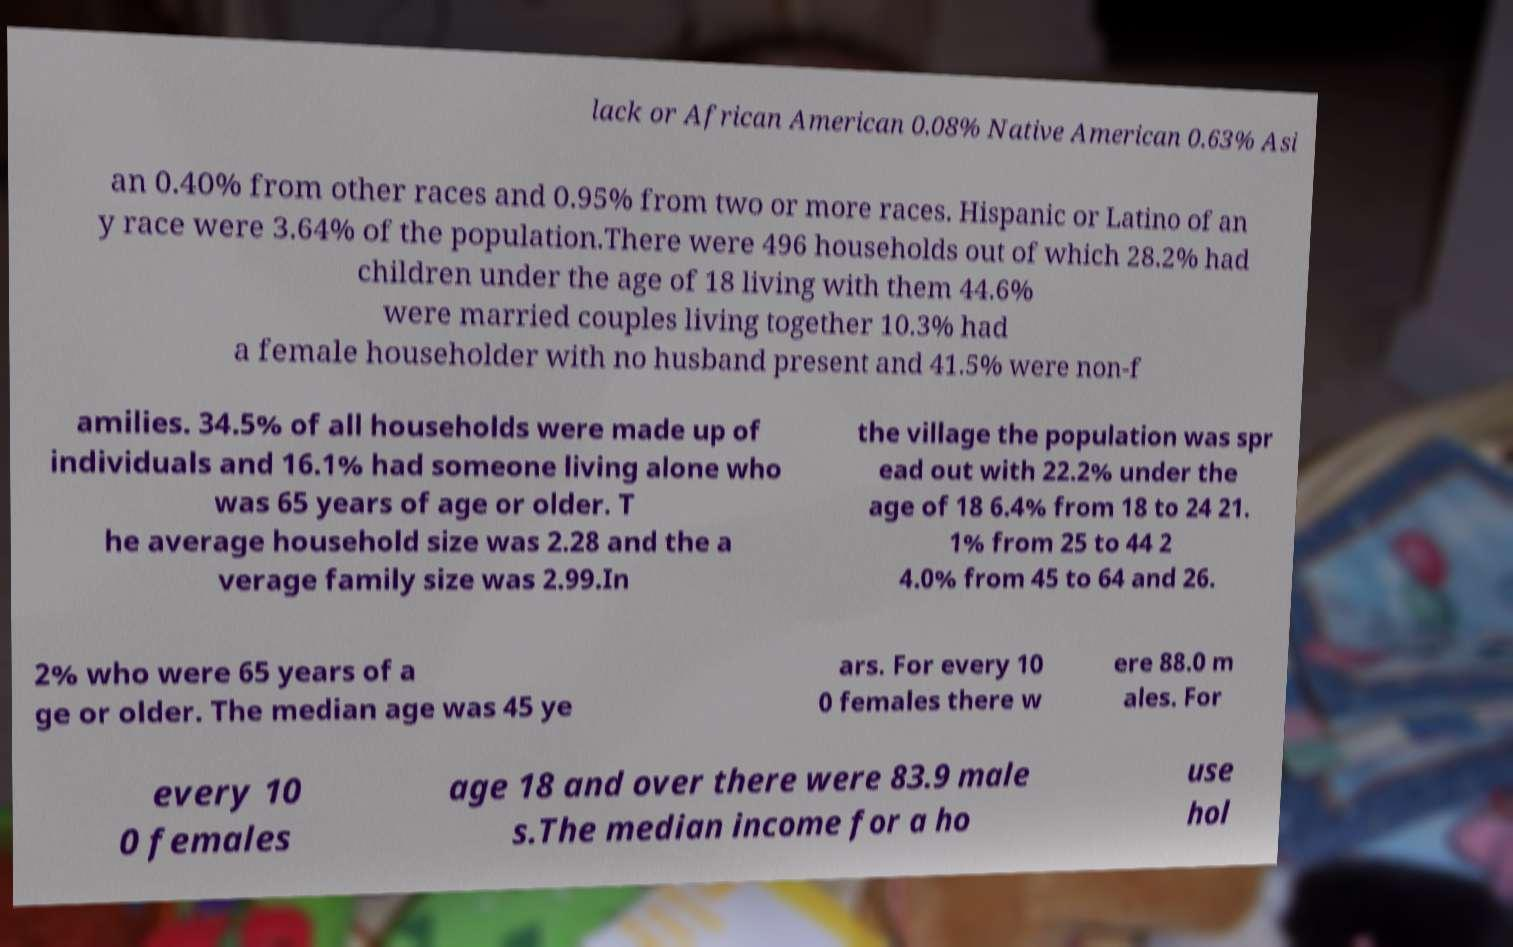I need the written content from this picture converted into text. Can you do that? lack or African American 0.08% Native American 0.63% Asi an 0.40% from other races and 0.95% from two or more races. Hispanic or Latino of an y race were 3.64% of the population.There were 496 households out of which 28.2% had children under the age of 18 living with them 44.6% were married couples living together 10.3% had a female householder with no husband present and 41.5% were non-f amilies. 34.5% of all households were made up of individuals and 16.1% had someone living alone who was 65 years of age or older. T he average household size was 2.28 and the a verage family size was 2.99.In the village the population was spr ead out with 22.2% under the age of 18 6.4% from 18 to 24 21. 1% from 25 to 44 2 4.0% from 45 to 64 and 26. 2% who were 65 years of a ge or older. The median age was 45 ye ars. For every 10 0 females there w ere 88.0 m ales. For every 10 0 females age 18 and over there were 83.9 male s.The median income for a ho use hol 